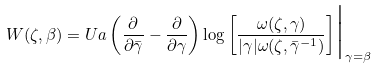<formula> <loc_0><loc_0><loc_500><loc_500>W ( \zeta , \beta ) = U a \left ( \frac { \partial } { \partial \bar { \gamma } } - \frac { \partial } { \partial \gamma } \right ) \log { \left [ \frac { \omega ( \zeta , \gamma ) } { | \gamma | \omega ( \zeta , \bar { \gamma } ^ { - 1 } ) } \right ] } \Big | _ { \gamma = \beta }</formula> 